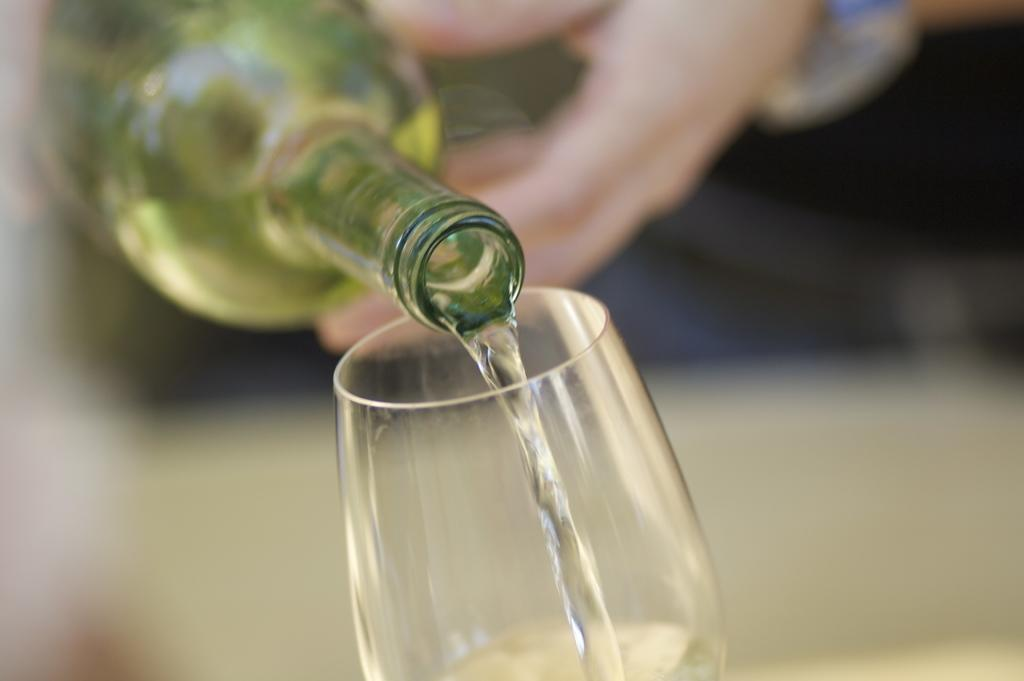Who is present in the image? There is a person in the image. What is the person doing in the image? The person is pouring water. What is the source of the water being poured? The water is being poured from a bottle. Where is the water being poured into? The water is being poured into a glass. What type of brass instrument is the person playing in the image? There is no brass instrument present in the image; the person is pouring water from a bottle into a glass. 